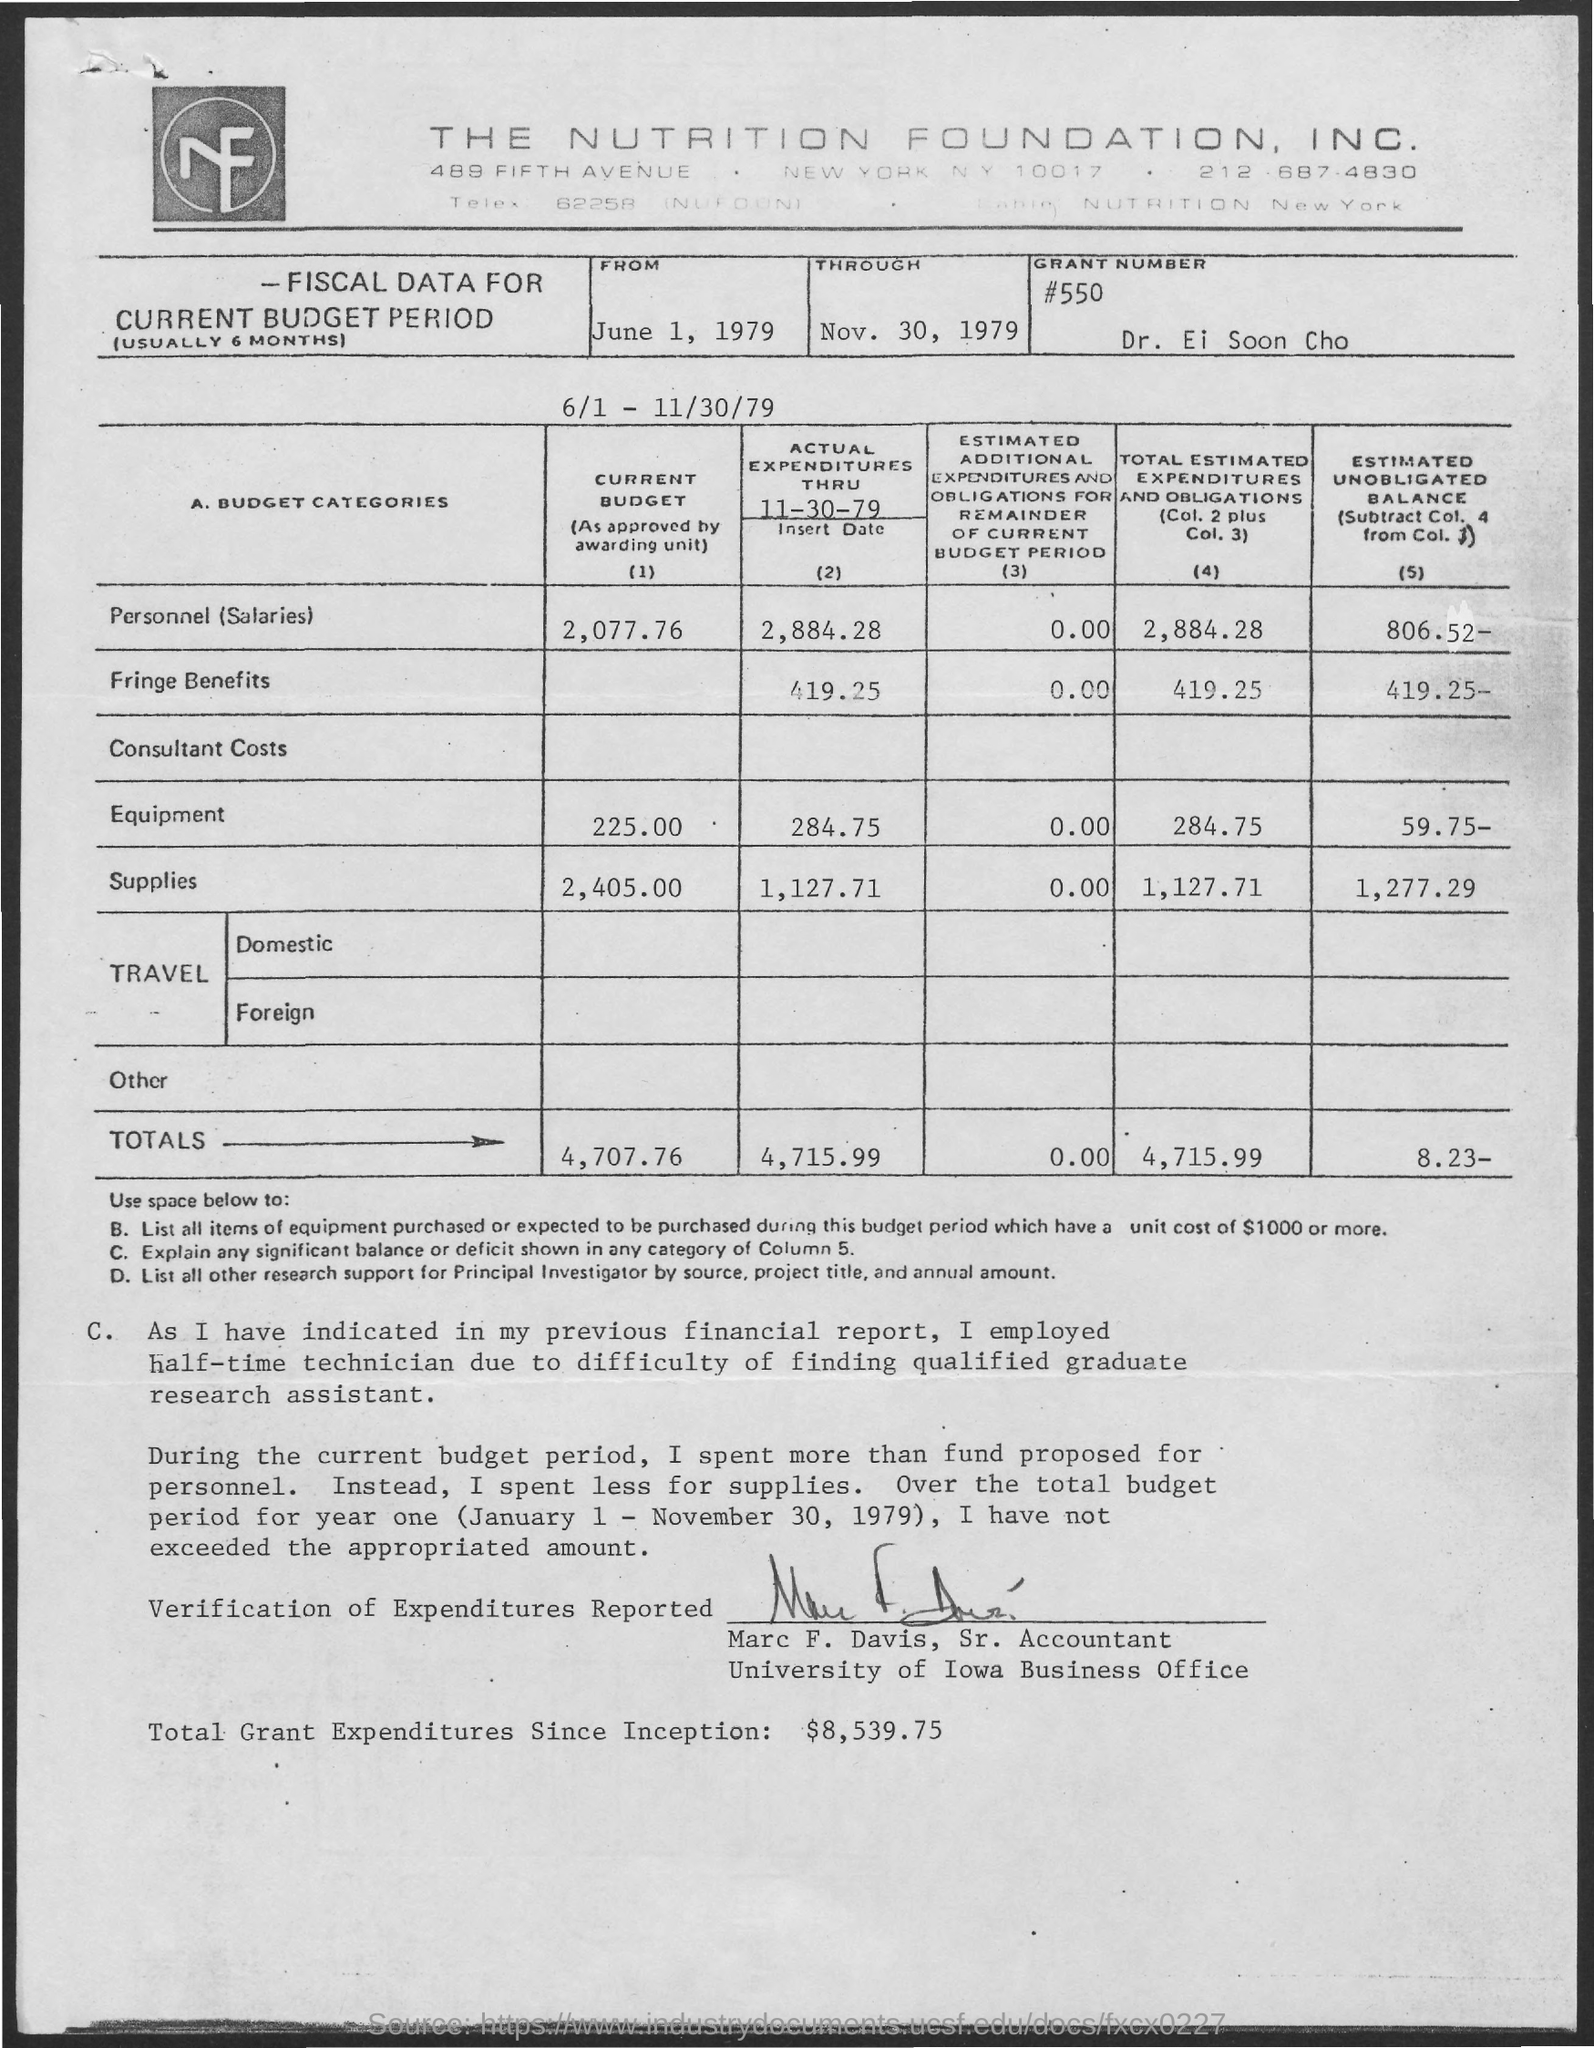Highlight a few significant elements in this photo. The total amount currently shown in the budget is 4,707.76. The current budget has a total of 2,405 supplies. The grant number mentioned in the given letter is #550. The current budget includes an amount of personnel salaries of 2,077.76. Marc F. Davis holds the designation of Senior Accountant. 